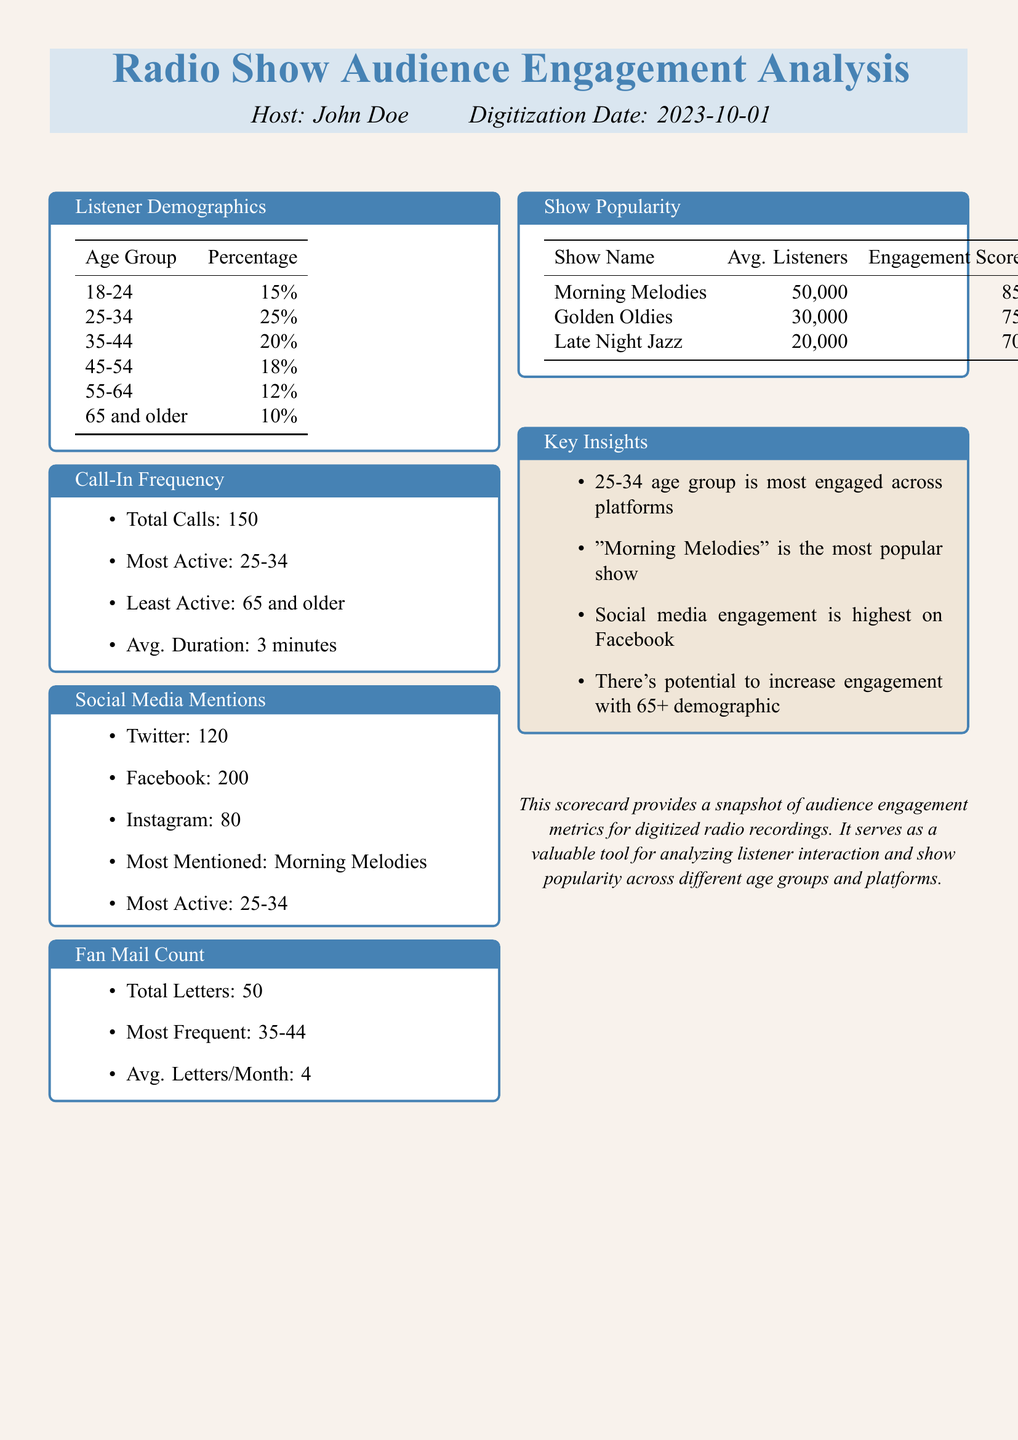what is the age group with the highest percentage of listeners? The audience demographics indicate that the 25-34 age group has the highest percentage of listeners at 25%.
Answer: 25-34 how many total calls were made to the show? The document states that a total of 150 calls were made to the show.
Answer: 150 which show had the highest average listeners? The show popularity section shows that "Morning Melodies" had the highest average listeners at 50,000.
Answer: Morning Melodies what is the most active age group for call-ins? According to the call-in frequency data, the most active age group for call-ins is 25-34.
Answer: 25-34 how many total fan mail letters were received? The fan mail count section details that a total of 50 letters were received.
Answer: 50 which social media platform had the most mentions? The social media mentions indicate that Facebook received the most mentions, with a count of 200.
Answer: Facebook what is the average engagement score for the show "Golden Oldies"? The show popularity section shows that "Golden Oldies" had an engagement score of 75.
Answer: 75 which age group is least active in call-ins? The call-in frequency indicates that the least active age group is those aged 65 and older.
Answer: 65 and older what is the average number of fan mail letters received per month? The fan mail count shows that the average letters per month are 4.
Answer: 4 